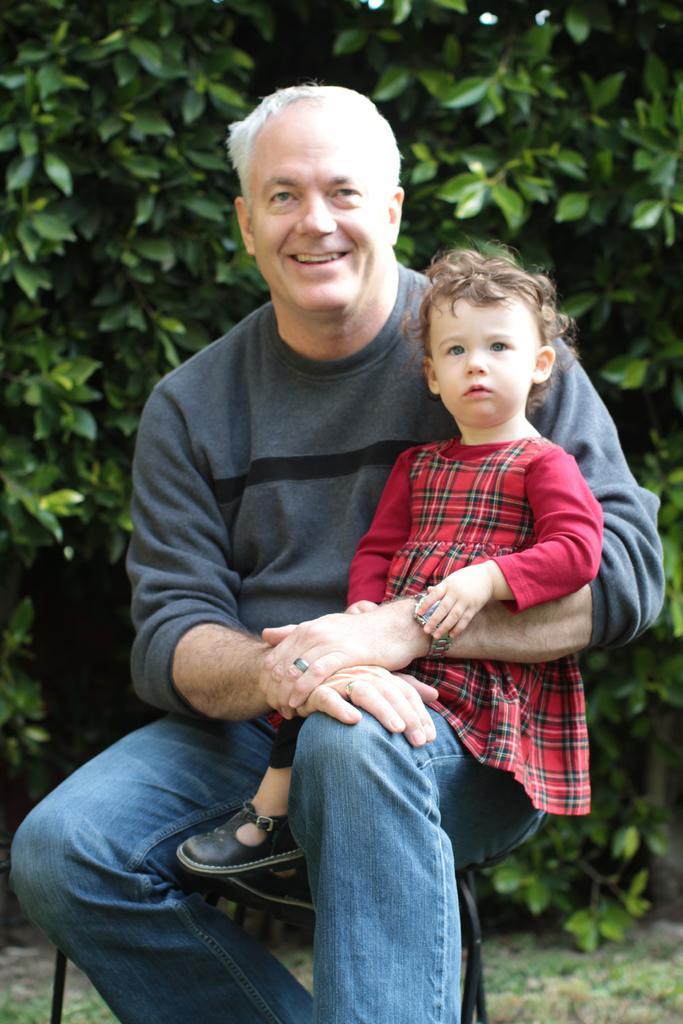Please provide a concise description of this image. In the image in the center we can see one man sitting on the chair and holding one baby and he is smiling,which we can see on his face. In the background we can see trees. 